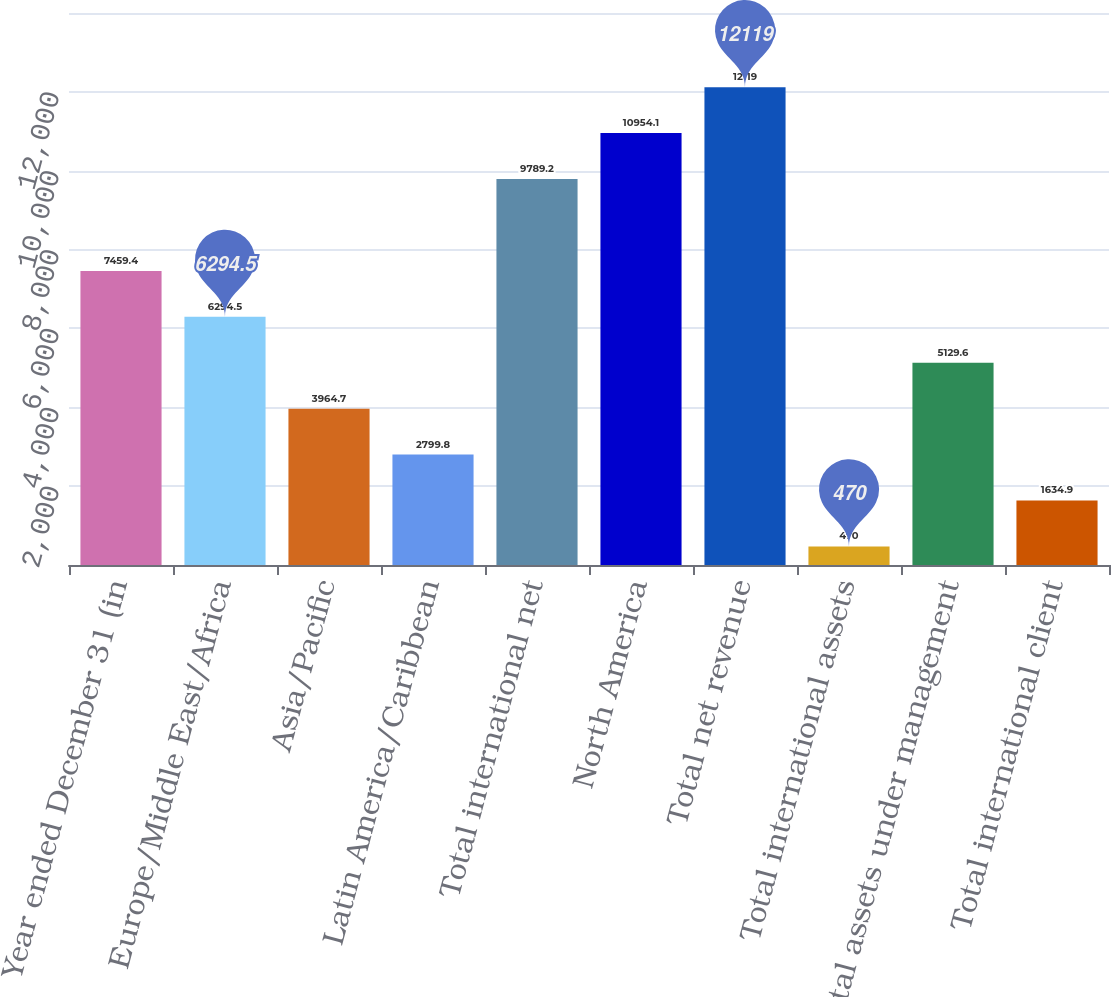Convert chart. <chart><loc_0><loc_0><loc_500><loc_500><bar_chart><fcel>Year ended December 31 (in<fcel>Europe/Middle East/Africa<fcel>Asia/Pacific<fcel>Latin America/Caribbean<fcel>Total international net<fcel>North America<fcel>Total net revenue<fcel>Total international assets<fcel>Total assets under management<fcel>Total international client<nl><fcel>7459.4<fcel>6294.5<fcel>3964.7<fcel>2799.8<fcel>9789.2<fcel>10954.1<fcel>12119<fcel>470<fcel>5129.6<fcel>1634.9<nl></chart> 